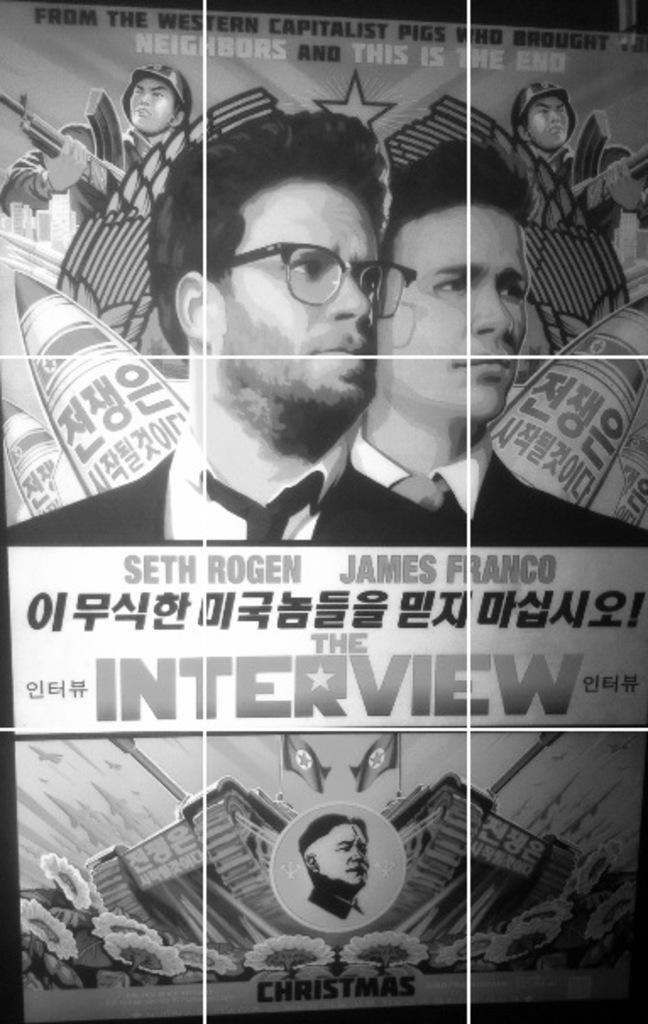What is the color scheme of the image? The image is black and white. What can be seen on the poster in the image? There are letters on the poster. How many people are present in the image? There are two people in the image. What type of structures are visible in the image? There are buildings in the image. What other elements can be seen in the image? There are flags and trees in the image. What type of mitten is being used to stir the kettle in the image? There is no mitten or kettle present in the image. How many buckets are visible in the image? There are no buckets visible in the image. 